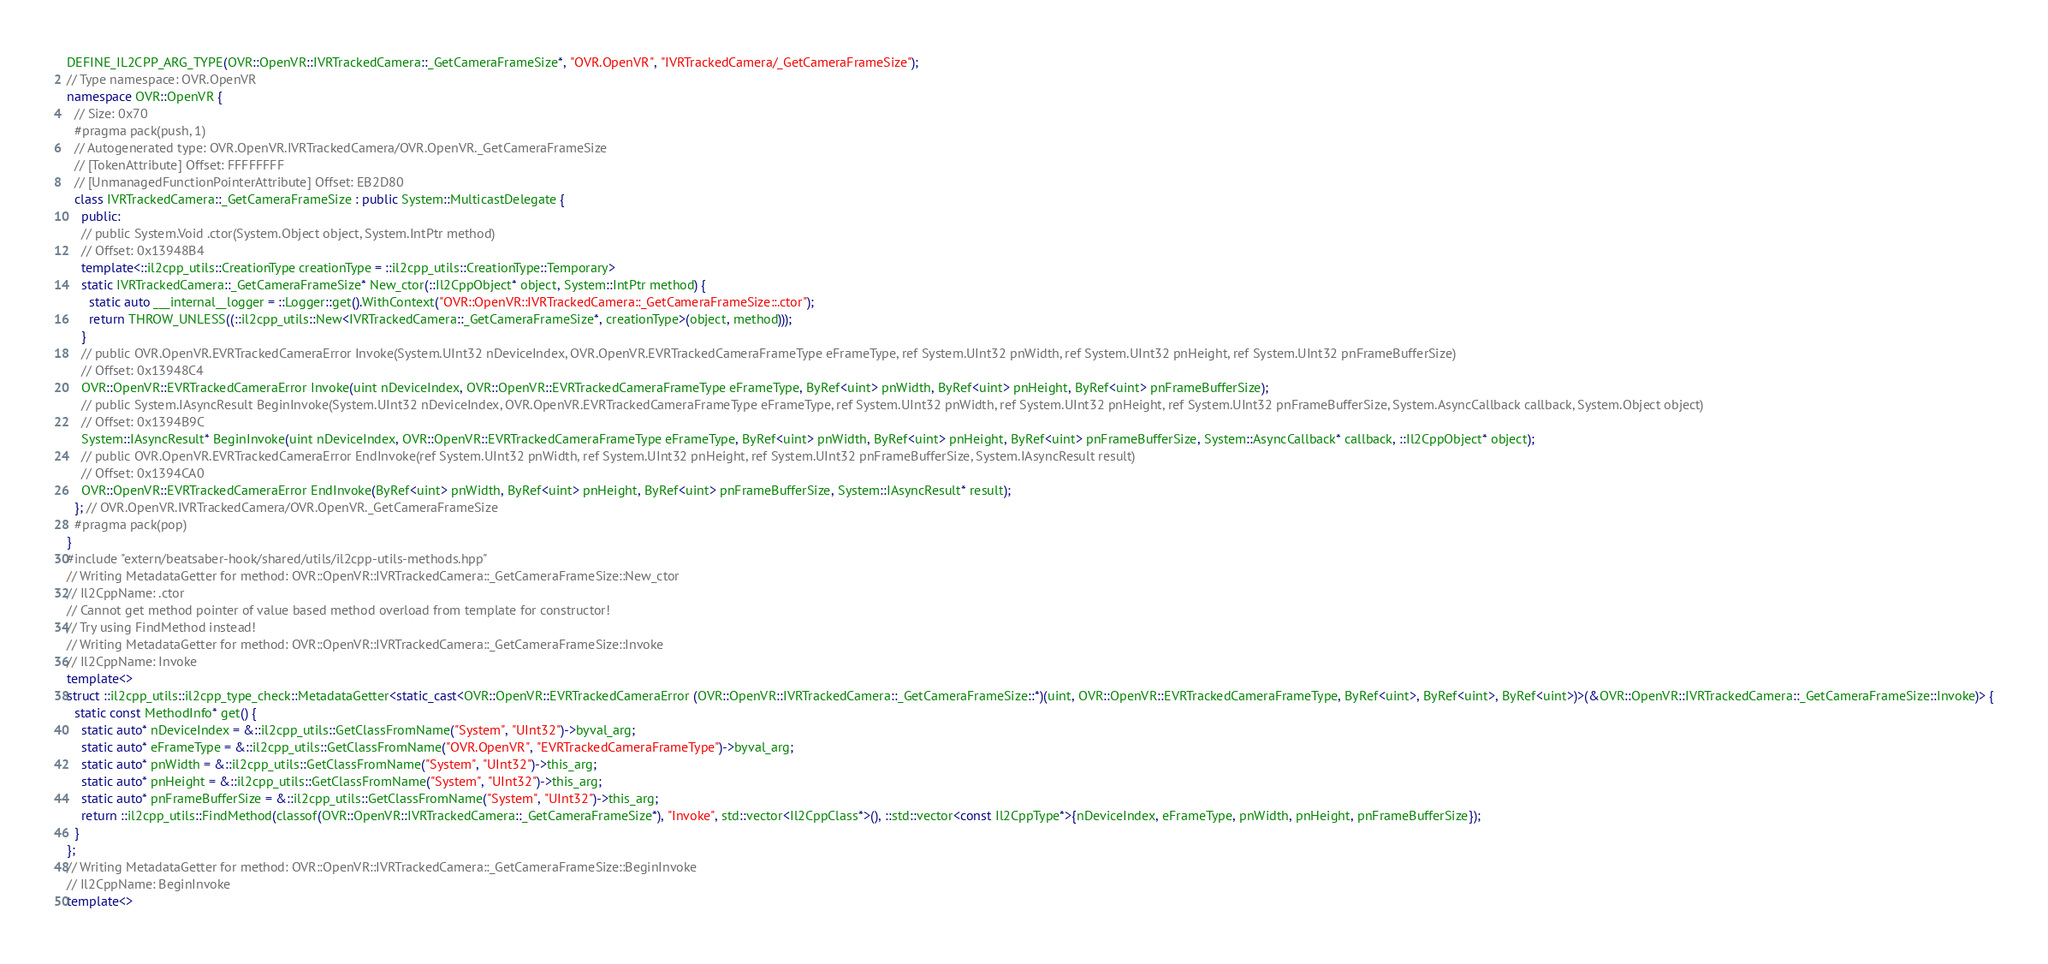Convert code to text. <code><loc_0><loc_0><loc_500><loc_500><_C++_>DEFINE_IL2CPP_ARG_TYPE(OVR::OpenVR::IVRTrackedCamera::_GetCameraFrameSize*, "OVR.OpenVR", "IVRTrackedCamera/_GetCameraFrameSize");
// Type namespace: OVR.OpenVR
namespace OVR::OpenVR {
  // Size: 0x70
  #pragma pack(push, 1)
  // Autogenerated type: OVR.OpenVR.IVRTrackedCamera/OVR.OpenVR._GetCameraFrameSize
  // [TokenAttribute] Offset: FFFFFFFF
  // [UnmanagedFunctionPointerAttribute] Offset: EB2D80
  class IVRTrackedCamera::_GetCameraFrameSize : public System::MulticastDelegate {
    public:
    // public System.Void .ctor(System.Object object, System.IntPtr method)
    // Offset: 0x13948B4
    template<::il2cpp_utils::CreationType creationType = ::il2cpp_utils::CreationType::Temporary>
    static IVRTrackedCamera::_GetCameraFrameSize* New_ctor(::Il2CppObject* object, System::IntPtr method) {
      static auto ___internal__logger = ::Logger::get().WithContext("OVR::OpenVR::IVRTrackedCamera::_GetCameraFrameSize::.ctor");
      return THROW_UNLESS((::il2cpp_utils::New<IVRTrackedCamera::_GetCameraFrameSize*, creationType>(object, method)));
    }
    // public OVR.OpenVR.EVRTrackedCameraError Invoke(System.UInt32 nDeviceIndex, OVR.OpenVR.EVRTrackedCameraFrameType eFrameType, ref System.UInt32 pnWidth, ref System.UInt32 pnHeight, ref System.UInt32 pnFrameBufferSize)
    // Offset: 0x13948C4
    OVR::OpenVR::EVRTrackedCameraError Invoke(uint nDeviceIndex, OVR::OpenVR::EVRTrackedCameraFrameType eFrameType, ByRef<uint> pnWidth, ByRef<uint> pnHeight, ByRef<uint> pnFrameBufferSize);
    // public System.IAsyncResult BeginInvoke(System.UInt32 nDeviceIndex, OVR.OpenVR.EVRTrackedCameraFrameType eFrameType, ref System.UInt32 pnWidth, ref System.UInt32 pnHeight, ref System.UInt32 pnFrameBufferSize, System.AsyncCallback callback, System.Object object)
    // Offset: 0x1394B9C
    System::IAsyncResult* BeginInvoke(uint nDeviceIndex, OVR::OpenVR::EVRTrackedCameraFrameType eFrameType, ByRef<uint> pnWidth, ByRef<uint> pnHeight, ByRef<uint> pnFrameBufferSize, System::AsyncCallback* callback, ::Il2CppObject* object);
    // public OVR.OpenVR.EVRTrackedCameraError EndInvoke(ref System.UInt32 pnWidth, ref System.UInt32 pnHeight, ref System.UInt32 pnFrameBufferSize, System.IAsyncResult result)
    // Offset: 0x1394CA0
    OVR::OpenVR::EVRTrackedCameraError EndInvoke(ByRef<uint> pnWidth, ByRef<uint> pnHeight, ByRef<uint> pnFrameBufferSize, System::IAsyncResult* result);
  }; // OVR.OpenVR.IVRTrackedCamera/OVR.OpenVR._GetCameraFrameSize
  #pragma pack(pop)
}
#include "extern/beatsaber-hook/shared/utils/il2cpp-utils-methods.hpp"
// Writing MetadataGetter for method: OVR::OpenVR::IVRTrackedCamera::_GetCameraFrameSize::New_ctor
// Il2CppName: .ctor
// Cannot get method pointer of value based method overload from template for constructor!
// Try using FindMethod instead!
// Writing MetadataGetter for method: OVR::OpenVR::IVRTrackedCamera::_GetCameraFrameSize::Invoke
// Il2CppName: Invoke
template<>
struct ::il2cpp_utils::il2cpp_type_check::MetadataGetter<static_cast<OVR::OpenVR::EVRTrackedCameraError (OVR::OpenVR::IVRTrackedCamera::_GetCameraFrameSize::*)(uint, OVR::OpenVR::EVRTrackedCameraFrameType, ByRef<uint>, ByRef<uint>, ByRef<uint>)>(&OVR::OpenVR::IVRTrackedCamera::_GetCameraFrameSize::Invoke)> {
  static const MethodInfo* get() {
    static auto* nDeviceIndex = &::il2cpp_utils::GetClassFromName("System", "UInt32")->byval_arg;
    static auto* eFrameType = &::il2cpp_utils::GetClassFromName("OVR.OpenVR", "EVRTrackedCameraFrameType")->byval_arg;
    static auto* pnWidth = &::il2cpp_utils::GetClassFromName("System", "UInt32")->this_arg;
    static auto* pnHeight = &::il2cpp_utils::GetClassFromName("System", "UInt32")->this_arg;
    static auto* pnFrameBufferSize = &::il2cpp_utils::GetClassFromName("System", "UInt32")->this_arg;
    return ::il2cpp_utils::FindMethod(classof(OVR::OpenVR::IVRTrackedCamera::_GetCameraFrameSize*), "Invoke", std::vector<Il2CppClass*>(), ::std::vector<const Il2CppType*>{nDeviceIndex, eFrameType, pnWidth, pnHeight, pnFrameBufferSize});
  }
};
// Writing MetadataGetter for method: OVR::OpenVR::IVRTrackedCamera::_GetCameraFrameSize::BeginInvoke
// Il2CppName: BeginInvoke
template<></code> 